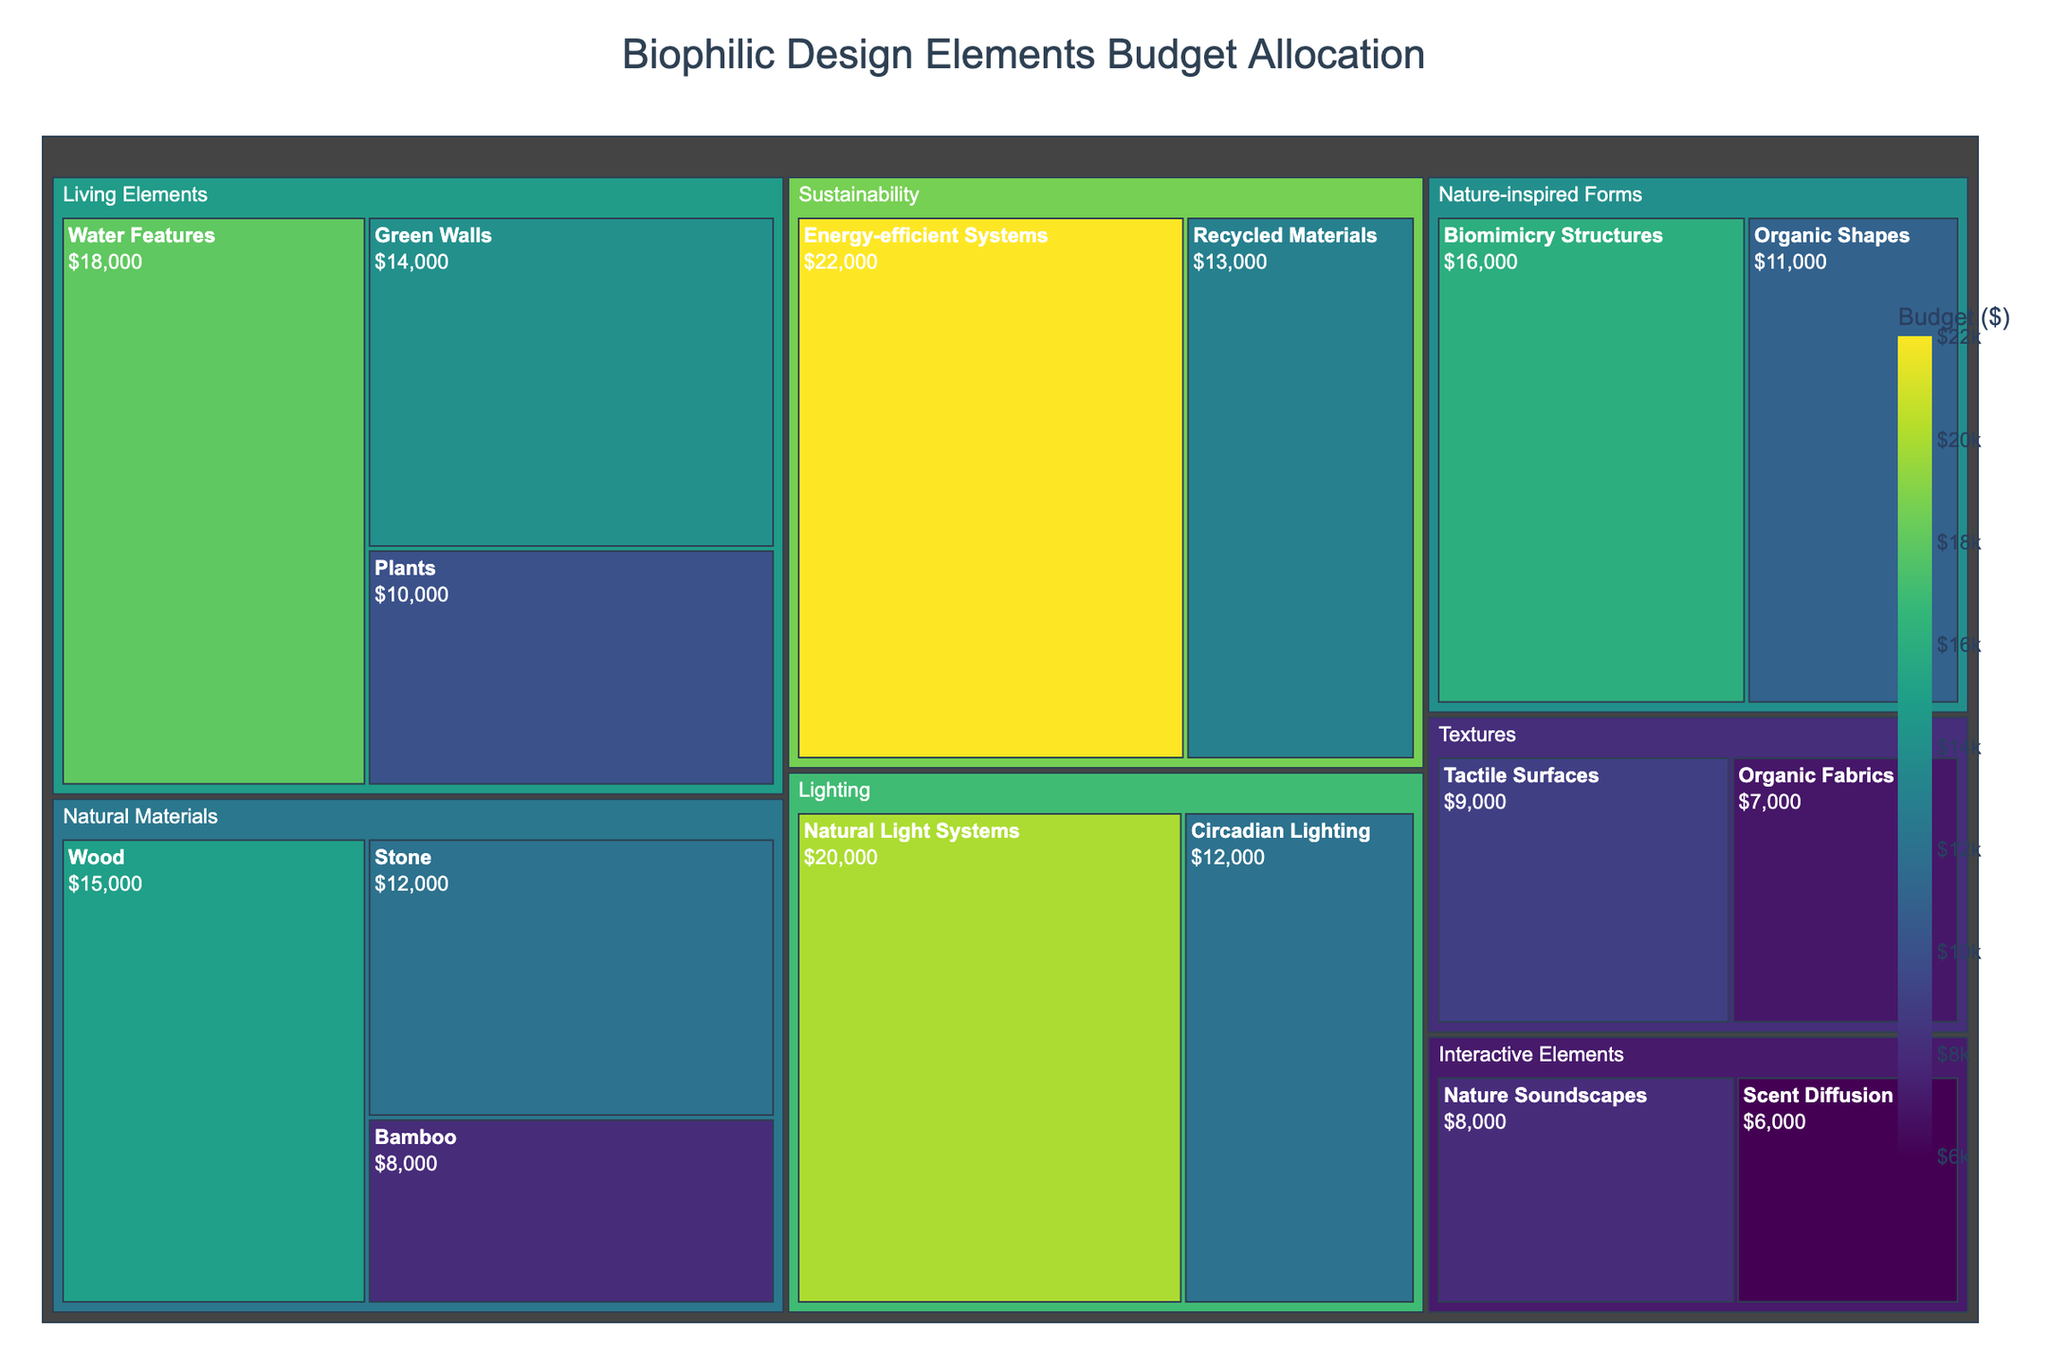Which category has the largest budget allocation? To determine the category with the largest budget allocation, examine the size of each category in the treemap. The largest rectangle will represent the highest budget.
Answer: Lighting What is the allocated budget for Stone under Natural Materials? Look for the 'Stone' subcategory within the 'Natural Materials' category and read the budget value.
Answer: $12,000 Which subcategory under Living Elements has the highest budget? Identify the subcategories under Living Elements and compare their budgets. The highest budget subcategory will have the largest rectangle.
Answer: Water Features How much more is allocated to Natural Light Systems compared to Circadian Lighting? Find the budgets for both Natural Light Systems and Circadian Lighting in the Lighting category and subtract the smaller budget from the larger one: $20,000 - $12,000.
Answer: $8,000 Which category has the smallest budget for its subcategories combined? Compare the total budget for each major category by summing its respective subcategories and identify the smallest one.
Answer: Textures What is the difference in budget allocation between Energy-efficient Systems and Recycled Materials? Locate both subcategories in the Sustainability category and find their budgets. Subtract the smaller from the larger: $22,000 - $13,000.
Answer: $9,000 Which category uses biophilic design principles related to living elements, and what's their total budget allocation? Identify the 'Living Elements' category and sum the budgets for its subcategories: Plants, Water Features, Green Walls (10,000 + 18,000 + 14,000).
Answer: $42,000 Are natural materials more budgeted than nature-inspired forms? Compare the total budget for the Natural Materials category and the Nature-inspired Forms category. Sum each subcategory's budget under both categories: (15,000 + 12,000 + 8,000) vs. (16,000 + 11,000).
Answer: Yes, Natural Materials are budgeted at $35,000 while Nature-inspired Forms are at $27,000 Which subcategory has the lowest budget across all categories? Identify and compare all the subcategories' budgets kept within the categories and find the smallest one.
Answer: Scent Diffusion 